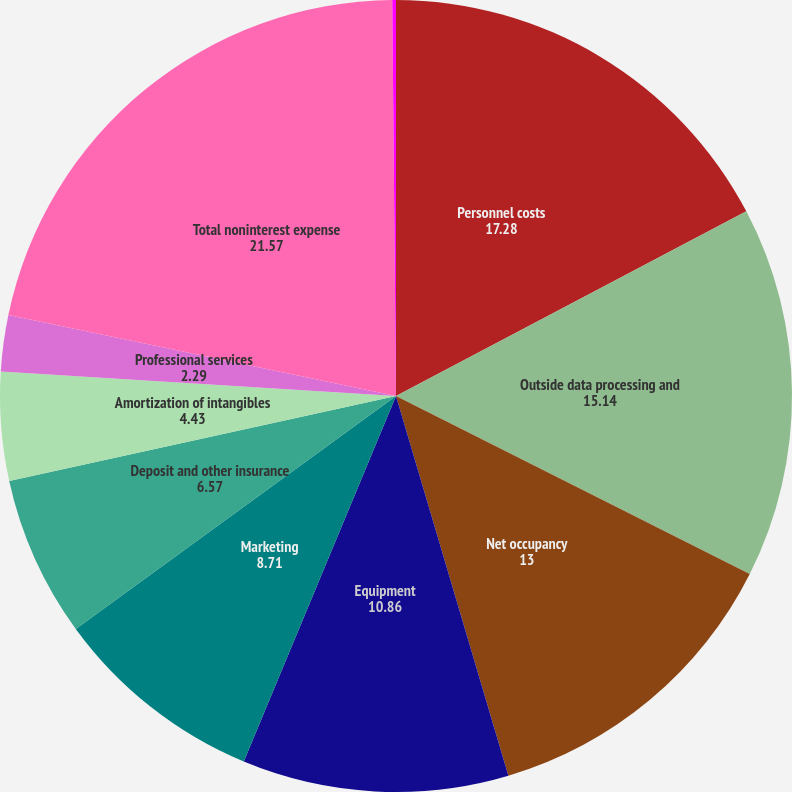Convert chart to OTSL. <chart><loc_0><loc_0><loc_500><loc_500><pie_chart><fcel>Personnel costs<fcel>Outside data processing and<fcel>Net occupancy<fcel>Equipment<fcel>Marketing<fcel>Deposit and other insurance<fcel>Amortization of intangibles<fcel>Professional services<fcel>Total noninterest expense<fcel>Number of employees (average<nl><fcel>17.28%<fcel>15.14%<fcel>13.0%<fcel>10.86%<fcel>8.71%<fcel>6.57%<fcel>4.43%<fcel>2.29%<fcel>21.57%<fcel>0.15%<nl></chart> 